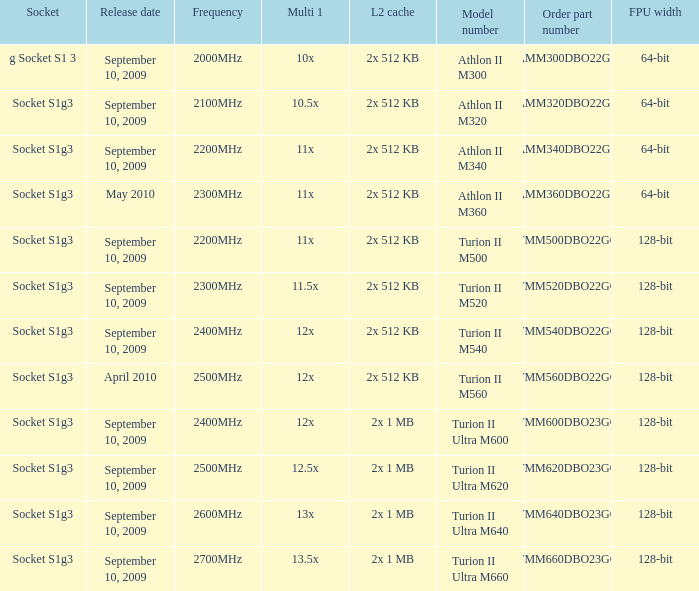What is the socket with an order part number of amm300dbo22gq and a September 10, 2009 release date? G socket s1 3. 